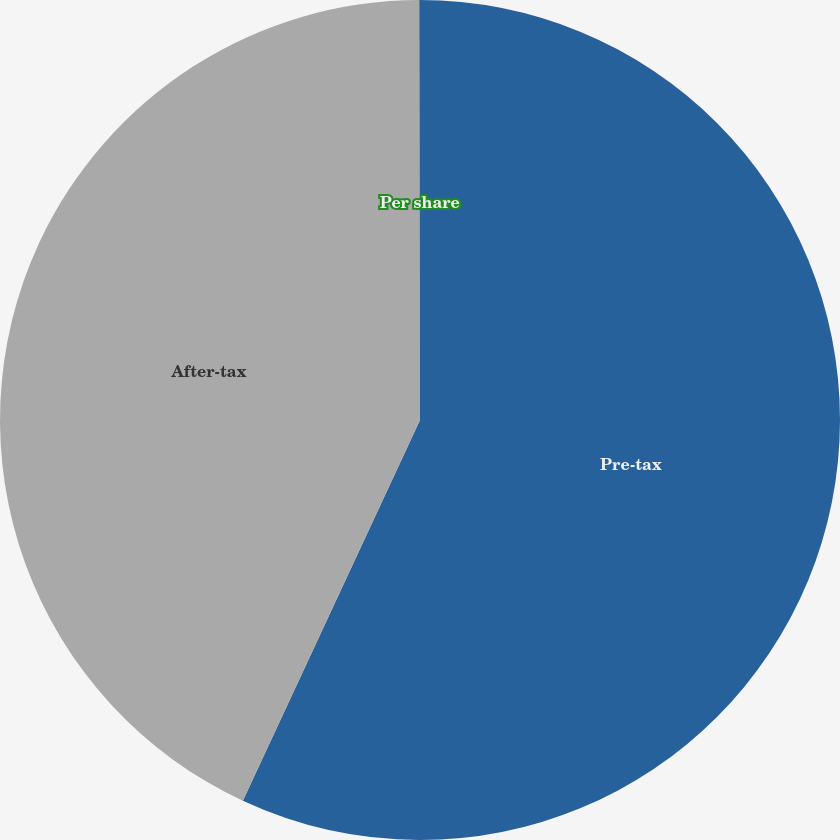Convert chart to OTSL. <chart><loc_0><loc_0><loc_500><loc_500><pie_chart><fcel>Pre-tax<fcel>After-tax<fcel>Per share<nl><fcel>56.93%<fcel>43.04%<fcel>0.03%<nl></chart> 